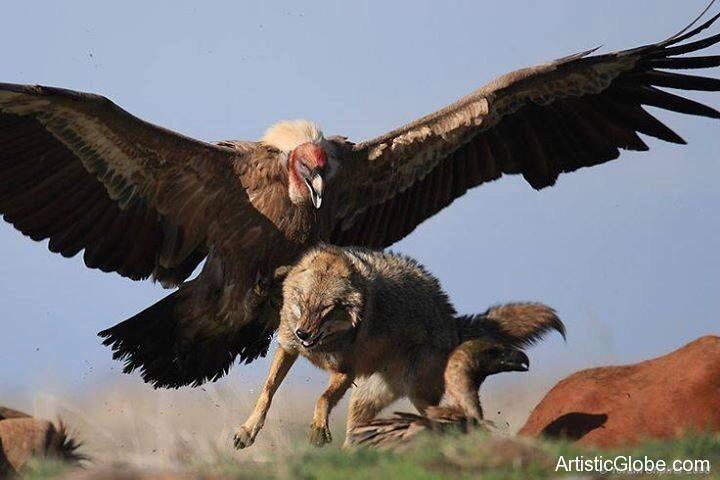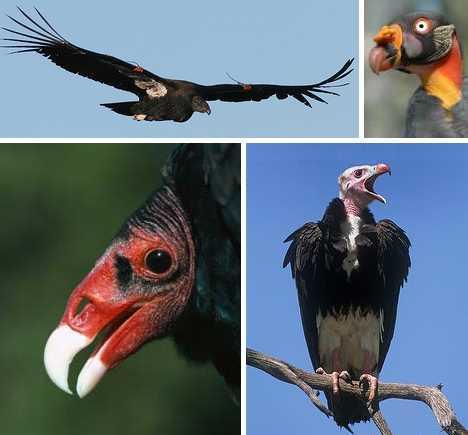The first image is the image on the left, the second image is the image on the right. Assess this claim about the two images: "The leftmost image in the pair is of a vulture, while the rightmost is of bald eagles.". Correct or not? Answer yes or no. No. The first image is the image on the left, the second image is the image on the right. Evaluate the accuracy of this statement regarding the images: "One of the images shows exactly one bald eagle with wings spread.". Is it true? Answer yes or no. No. 